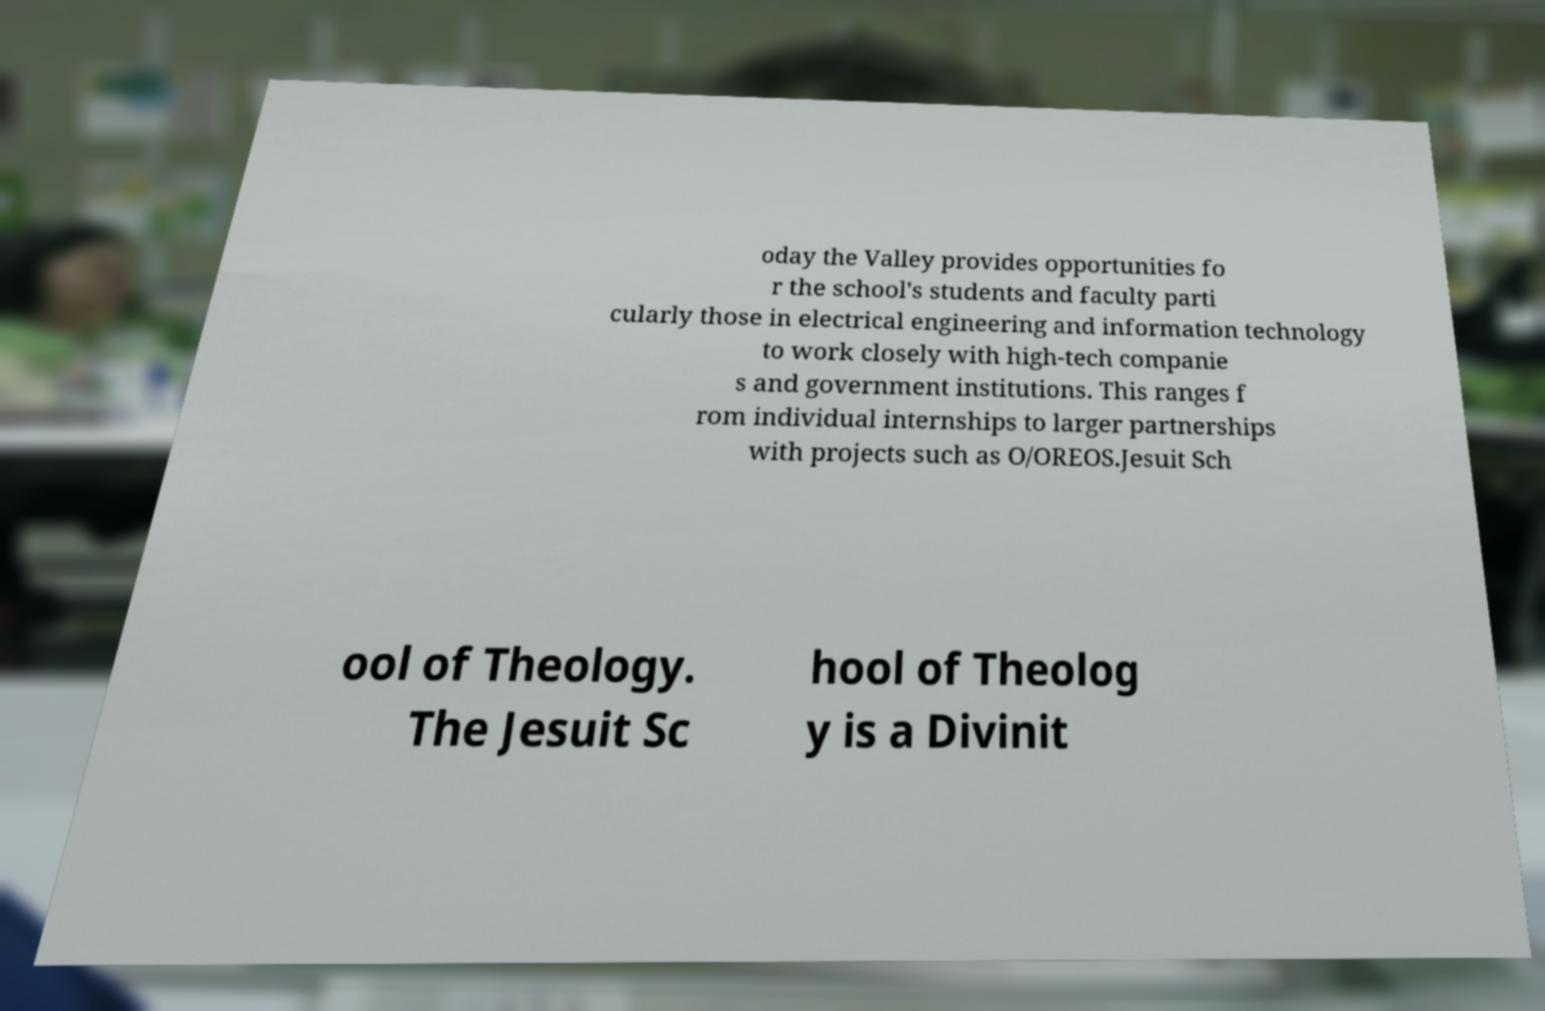Could you extract and type out the text from this image? oday the Valley provides opportunities fo r the school's students and faculty parti cularly those in electrical engineering and information technology to work closely with high-tech companie s and government institutions. This ranges f rom individual internships to larger partnerships with projects such as O/OREOS.Jesuit Sch ool of Theology. The Jesuit Sc hool of Theolog y is a Divinit 